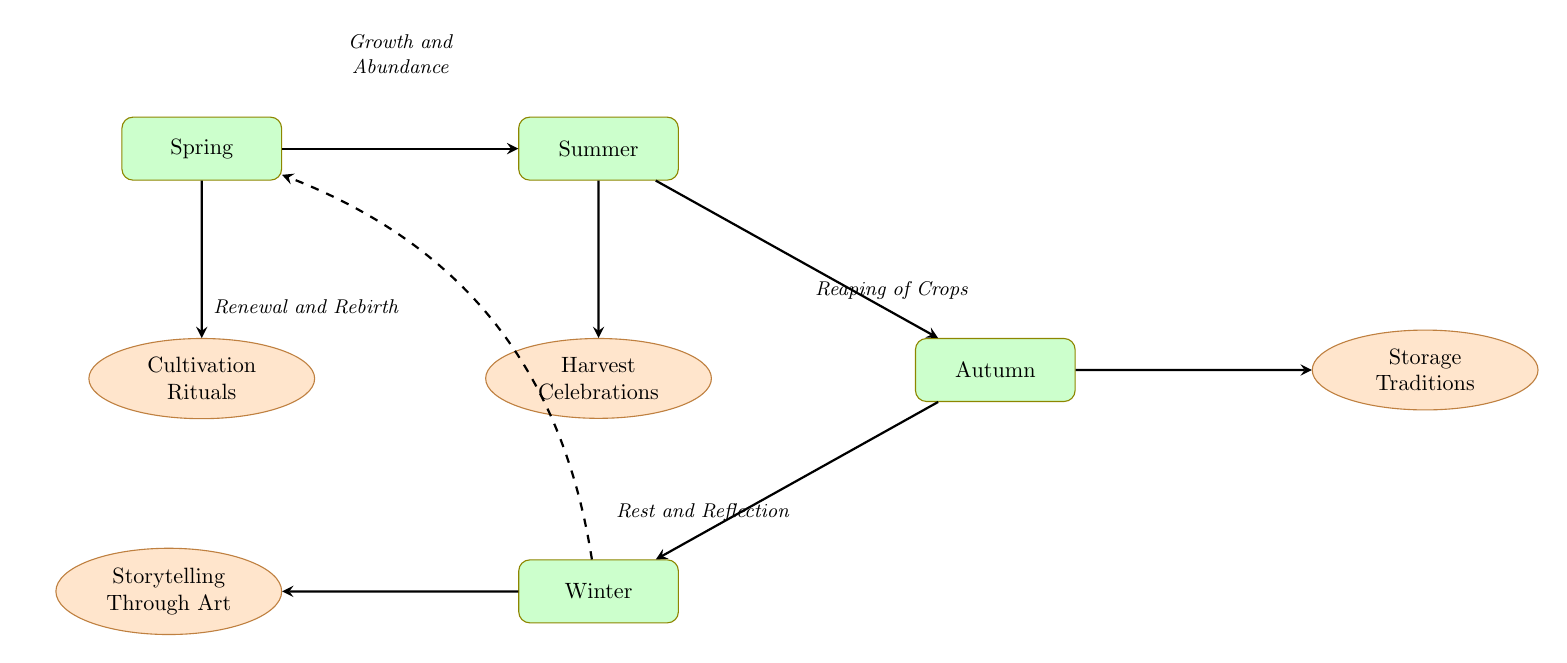What are the two seasons directly connected to Spring? The arrows connected to Spring lead to Summer and Cultivation Rituals. Thus, the two nodes connected directly to Spring are Summer and Cultivation Rituals.
Answer: Summer, Cultivation Rituals How many nodes are present in the diagram? By counting each unique node listed and represented in the diagram (Spring, Summer, Autumn, Winter, Cultivation Rituals, Harvest Celebrations, Storage Traditions, Storytelling Through Art), there are a total of eight nodes.
Answer: 8 What is the relationship between Autumn and Winter? There is a direct arrow from Autumn to Winter, indicating a one-way relationship, where Autumn directly leads to Winter in the flow of the diagram.
Answer: Autumn leads to Winter Which season is depicted as the time of festivals marking the end of the harvest? The node labeled Harvest Celebrations indicates that it is the representation of festivals marking the end of the harvest season, connecting it to the Summer season.
Answer: Harvest Celebrations What tradition is depicted after Winter in the diagram? From the edge leading out from Winter, it connects to the node titled Storytelling Through Art, indicating that this tradition follows Winter in the sequence.
Answer: Storytelling Through Art Which season symbolizes renewal and rebirth according to the diagram? The description associated with Spring emphasizes its themes of planting and renewal, therefore symbolizing renewal and rebirth.
Answer: Spring What type of art is associated with the season of Autumn? Autumn is connected to Storage Traditions, which are traditional methods for storing food and supplies for the winter, indicating that this type of craft is associated with the Autumn season.
Answer: Storage Traditions How many edges are there in the flow chart? Counting the connections (edges) between the nodes, there are seven arrows leading from one node to another, representing the relationships among the nodes.
Answer: 7 